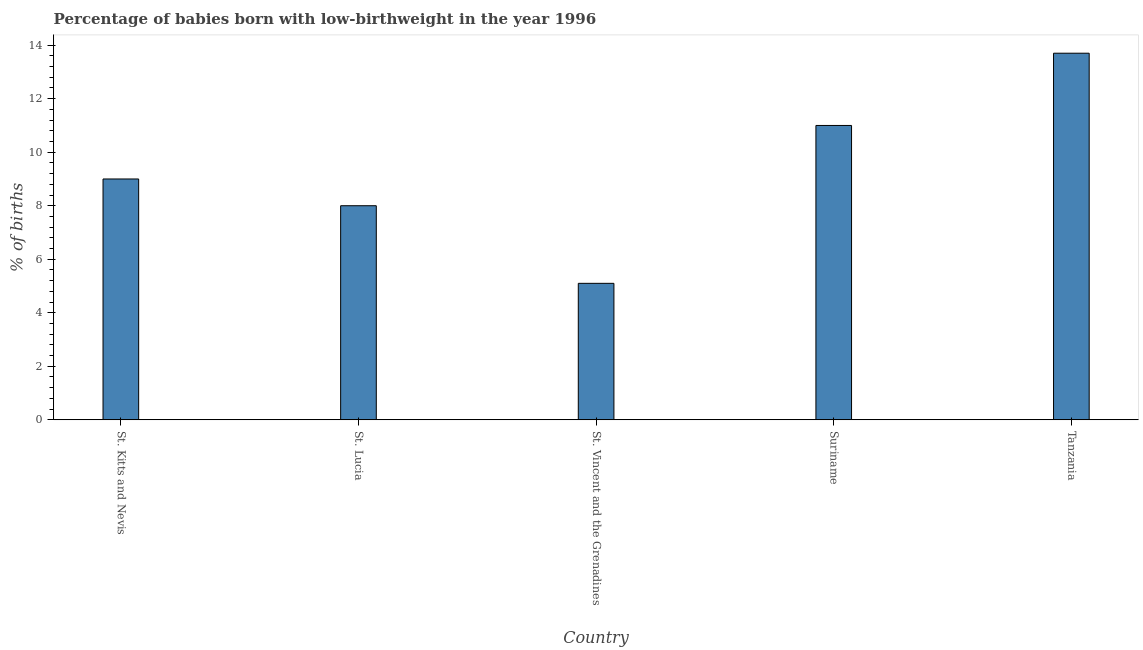Does the graph contain any zero values?
Provide a short and direct response. No. What is the title of the graph?
Give a very brief answer. Percentage of babies born with low-birthweight in the year 1996. What is the label or title of the X-axis?
Your response must be concise. Country. What is the label or title of the Y-axis?
Your answer should be compact. % of births. What is the percentage of babies who were born with low-birthweight in Suriname?
Provide a succinct answer. 11. Across all countries, what is the maximum percentage of babies who were born with low-birthweight?
Provide a succinct answer. 13.7. In which country was the percentage of babies who were born with low-birthweight maximum?
Your answer should be compact. Tanzania. In which country was the percentage of babies who were born with low-birthweight minimum?
Make the answer very short. St. Vincent and the Grenadines. What is the sum of the percentage of babies who were born with low-birthweight?
Your answer should be compact. 46.8. What is the difference between the percentage of babies who were born with low-birthweight in St. Kitts and Nevis and St. Vincent and the Grenadines?
Ensure brevity in your answer.  3.9. What is the average percentage of babies who were born with low-birthweight per country?
Keep it short and to the point. 9.36. What is the median percentage of babies who were born with low-birthweight?
Ensure brevity in your answer.  9. In how many countries, is the percentage of babies who were born with low-birthweight greater than 8 %?
Your answer should be very brief. 3. What is the ratio of the percentage of babies who were born with low-birthweight in St. Vincent and the Grenadines to that in Tanzania?
Give a very brief answer. 0.37. Is the percentage of babies who were born with low-birthweight in Suriname less than that in Tanzania?
Provide a short and direct response. Yes. Is the difference between the percentage of babies who were born with low-birthweight in St. Vincent and the Grenadines and Suriname greater than the difference between any two countries?
Your response must be concise. No. What is the difference between the highest and the second highest percentage of babies who were born with low-birthweight?
Provide a short and direct response. 2.7. Is the sum of the percentage of babies who were born with low-birthweight in St. Kitts and Nevis and St. Vincent and the Grenadines greater than the maximum percentage of babies who were born with low-birthweight across all countries?
Your answer should be compact. Yes. How many bars are there?
Keep it short and to the point. 5. Are all the bars in the graph horizontal?
Provide a succinct answer. No. How many countries are there in the graph?
Your answer should be compact. 5. What is the % of births in St. Kitts and Nevis?
Your answer should be compact. 9. What is the % of births in St. Vincent and the Grenadines?
Make the answer very short. 5.1. What is the % of births of Suriname?
Your answer should be very brief. 11. What is the % of births in Tanzania?
Give a very brief answer. 13.7. What is the difference between the % of births in St. Lucia and St. Vincent and the Grenadines?
Your response must be concise. 2.9. What is the difference between the % of births in St. Lucia and Suriname?
Provide a short and direct response. -3. What is the difference between the % of births in Suriname and Tanzania?
Offer a terse response. -2.7. What is the ratio of the % of births in St. Kitts and Nevis to that in St. Lucia?
Provide a succinct answer. 1.12. What is the ratio of the % of births in St. Kitts and Nevis to that in St. Vincent and the Grenadines?
Offer a very short reply. 1.76. What is the ratio of the % of births in St. Kitts and Nevis to that in Suriname?
Your answer should be very brief. 0.82. What is the ratio of the % of births in St. Kitts and Nevis to that in Tanzania?
Provide a succinct answer. 0.66. What is the ratio of the % of births in St. Lucia to that in St. Vincent and the Grenadines?
Your answer should be very brief. 1.57. What is the ratio of the % of births in St. Lucia to that in Suriname?
Make the answer very short. 0.73. What is the ratio of the % of births in St. Lucia to that in Tanzania?
Offer a very short reply. 0.58. What is the ratio of the % of births in St. Vincent and the Grenadines to that in Suriname?
Offer a very short reply. 0.46. What is the ratio of the % of births in St. Vincent and the Grenadines to that in Tanzania?
Your response must be concise. 0.37. What is the ratio of the % of births in Suriname to that in Tanzania?
Offer a very short reply. 0.8. 